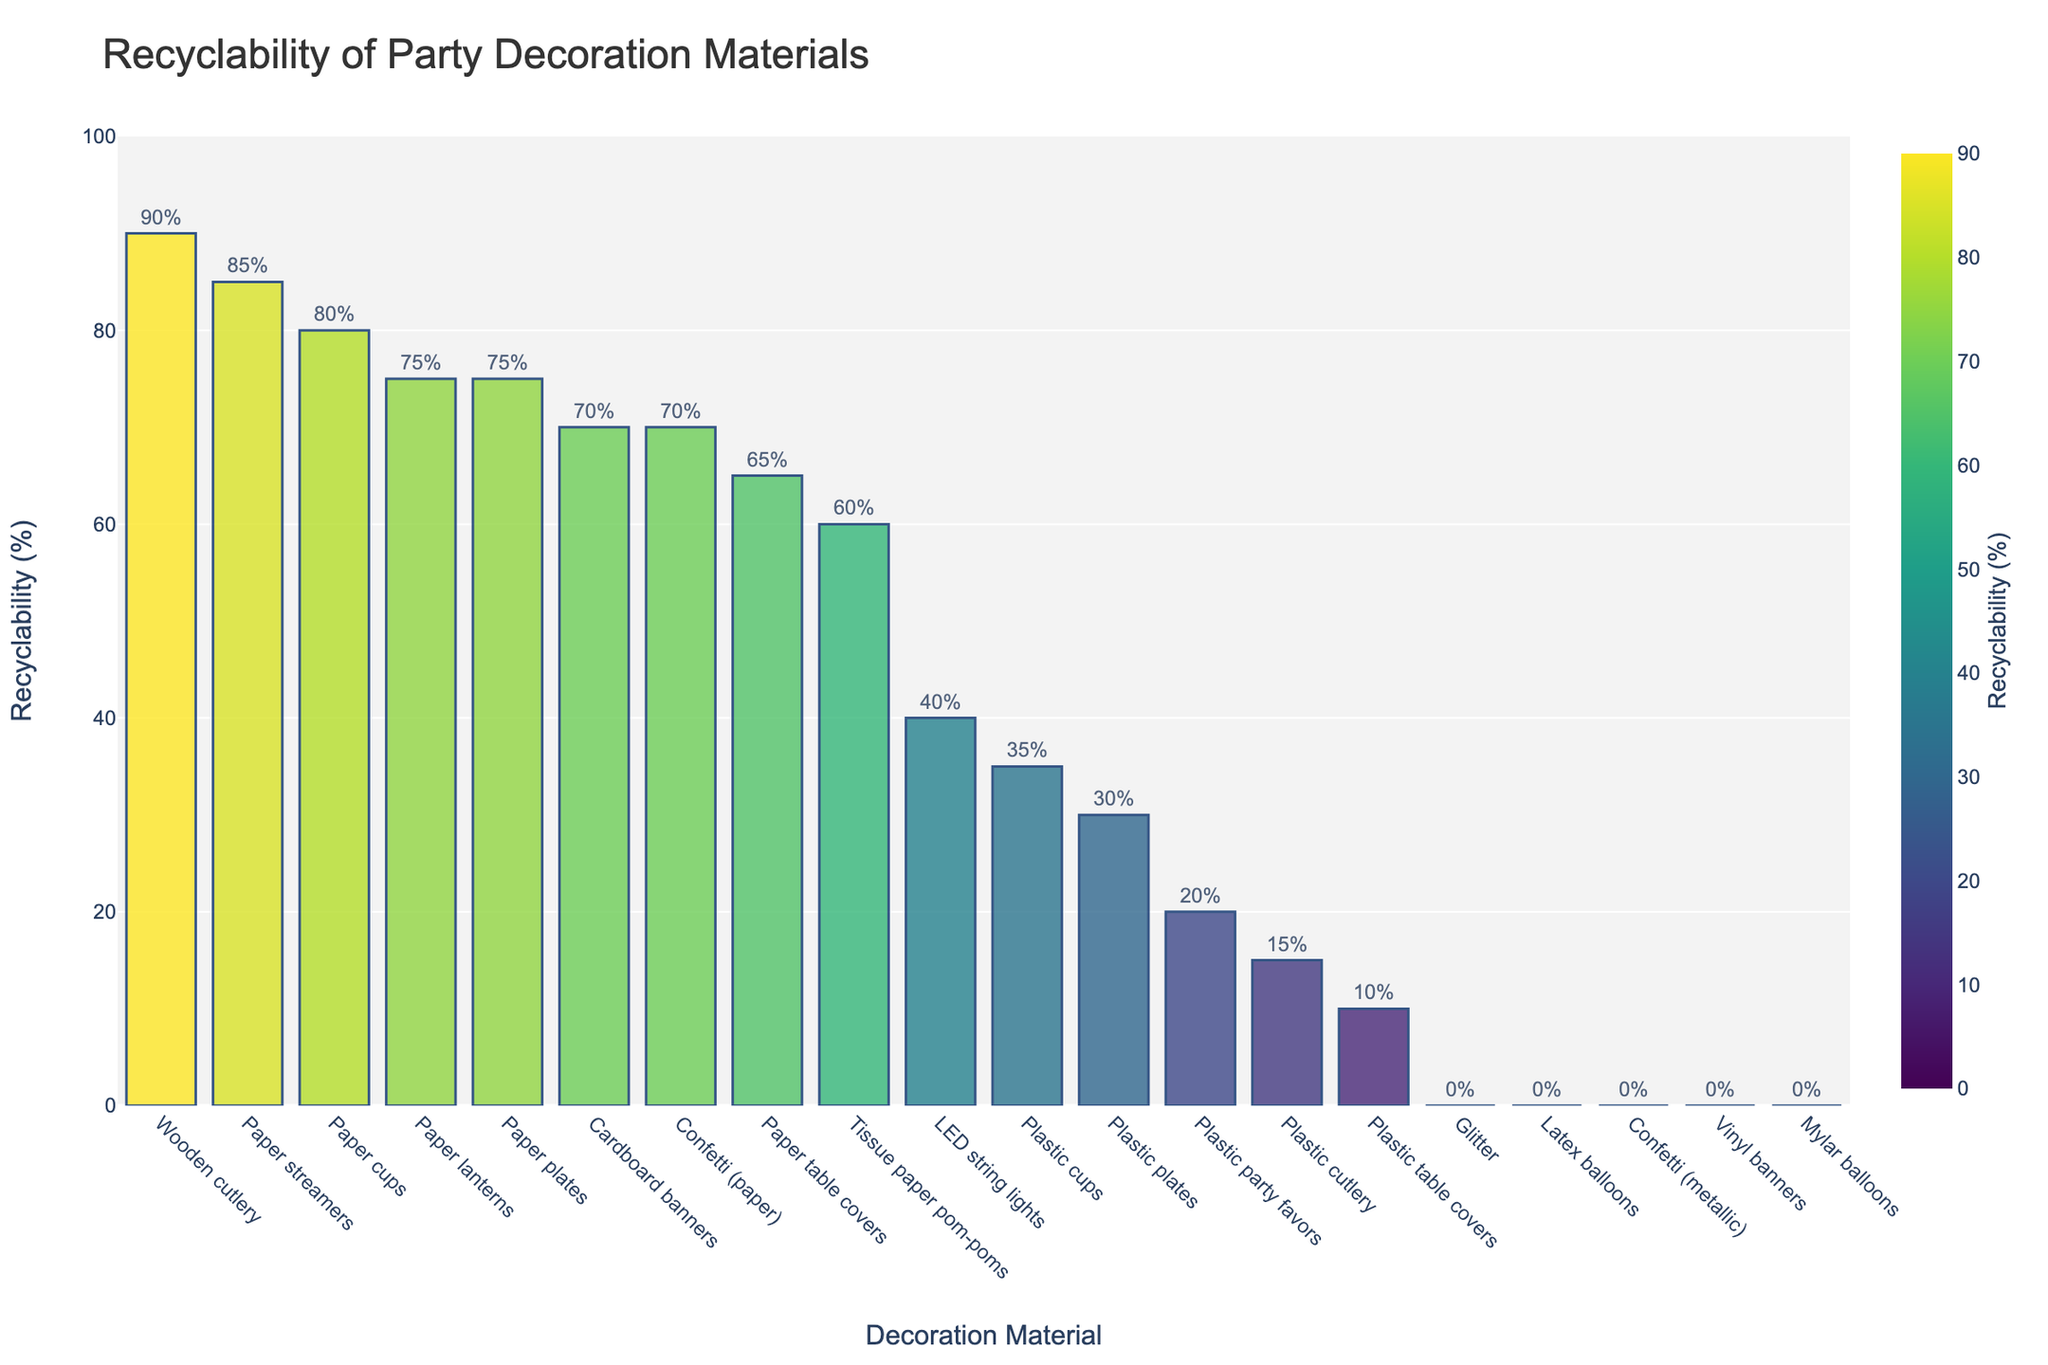Which party decoration material has the highest recyclability percentage? The bar chart shows that wooden cutlery has the highest recyclability percentage.
Answer: Wooden cutlery Which materials have a recyclability percentage of 0%? The bar chart indicates that latex balloons, mylar balloons, vinyl banners, glitter, and metallic confetti have 0% recyclability.
Answer: Latex balloons, mylar balloons, vinyl banners, glitter, metallic confetti How does the recyclability percentage of paper plates compare to plastic plates? The bar chart shows that paper plates have a recyclability percentage of 75%, while plastic plates have 30%. Therefore, paper plates are more recyclable than plastic plates.
Answer: Paper plates are more recyclable What is the average recyclability percentage of paper-based materials? (Consider paper streamers, paper plates, paper cups, cardboard banners, tissue paper pom-poms, paper table covers, paper lanterns, and paper confetti) Adding the recyclability percentages of paper-based materials (85 + 75 + 80 + 70 + 60 + 65 + 75 + 70) gives 580. Dividing by the number of materials (8) gives an average recyclability percentage of 72.5%.
Answer: 72.5% Compare the recyclability of paper cups and plastic cups. Which is more recyclable and by how much? The bar chart shows that paper cups have a recyclability percentage of 80%, and plastic cups have 35%. The difference in recyclability is 80% - 35% = 45%. Thus, paper cups are 45% more recyclable than plastic cups.
Answer: Paper cups are 45% more recyclable What is the recyclability percentage difference between the most and least recyclable materials? The most recyclable material is wooden cutlery with 90%, and the least recyclable materials include latex balloons, mylar balloons, vinyl banners, glitter, and metallic confetti at 0%. The difference is 90% - 0% = 90%.
Answer: 90% Identify the materials with recyclability percentages greater than 50%. The bar chart identifies that paper streamers, paper plates, paper cups, cardboard banners, tissue paper pom-poms, paper table covers, wooden cutlery, paper lanterns, and paper confetti all have recyclability percentages greater than 50%.
Answer: Paper streamers, paper plates, paper cups, cardboard banners, tissue paper pom-poms, paper table covers, wooden cutlery, paper lanterns, paper confetti 